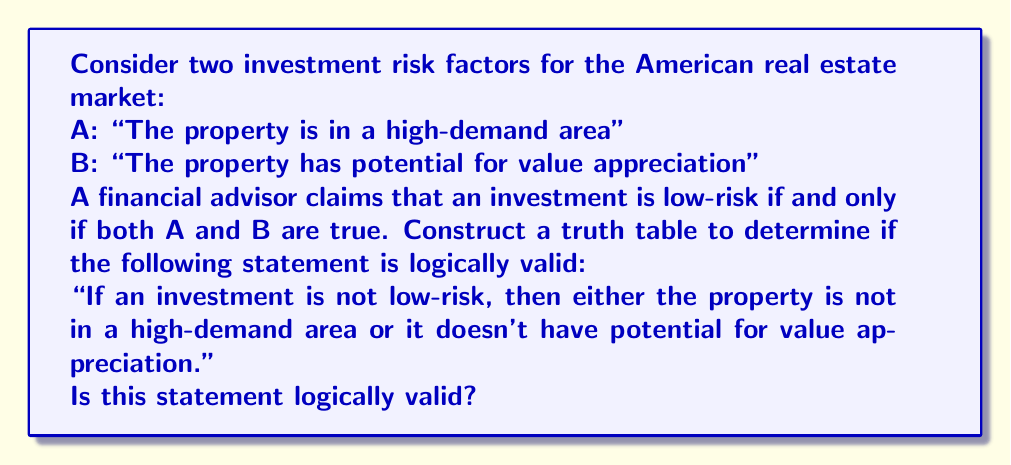Could you help me with this problem? To determine the logical validity of this statement, we need to construct a truth table and analyze it. Let's break it down step by step:

1. Define the variables:
   A: "The property is in a high-demand area"
   B: "The property has potential for value appreciation"
   L: "The investment is low-risk"

2. Express the given conditions:
   L ↔ (A ∧ B)  (low-risk if and only if both A and B are true)

3. Express the statement to be evaluated:
   ¬L → (¬A ∨ ¬B)

4. Construct the truth table:

   $$
   \begin{array}{|c|c|c|c|c|c|}
   \hline
   A & B & L & ¬L & ¬A ∨ ¬B & ¬L → (¬A ∨ ¬B) \\
   \hline
   T & T & T & F & F & T \\
   T & F & F & T & T & T \\
   F & T & F & T & T & T \\
   F & F & F & T & T & T \\
   \hline
   \end{array}
   $$

5. Analyze the truth table:
   - Column L is determined by (A ∧ B)
   - The last column represents the logical validity of the statement
   - For a statement to be logically valid, the last column must be true for all possible combinations of A and B

6. Observe that the last column is true for all rows, which means the statement is logically valid.

This logical validity can be interpreted in the context of real estate investment:
- When an investment is not low-risk (¬L is true), it implies that at least one of the conditions (high-demand area or potential for value appreciation) is not met.
- This aligns with the original claim that both conditions must be true for an investment to be considered low-risk.
Answer: The statement "If an investment is not low-risk, then either the property is not in a high-demand area or it doesn't have potential for value appreciation" is logically valid. This conclusion is based on the truth table analysis, which shows that the implication (¬L → (¬A ∨ ¬B)) is true for all possible combinations of A and B. 